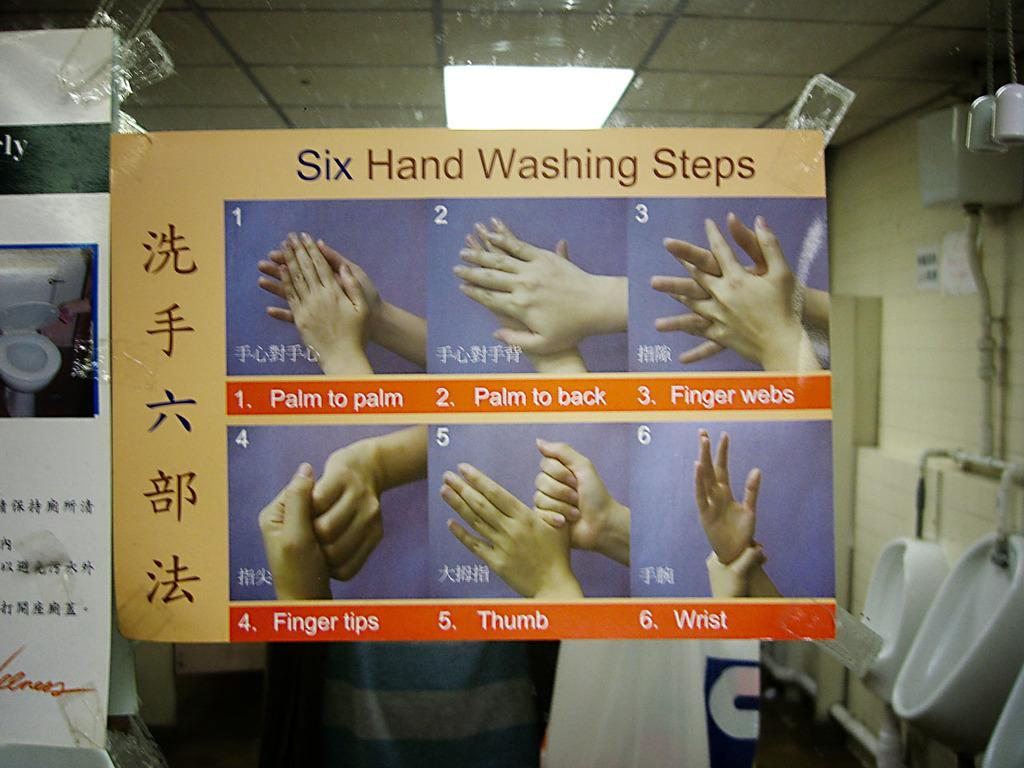Provide a one-sentence caption for the provided image. paper showing pictures of hands and the words "Six Hand Washing Steps" on top. 